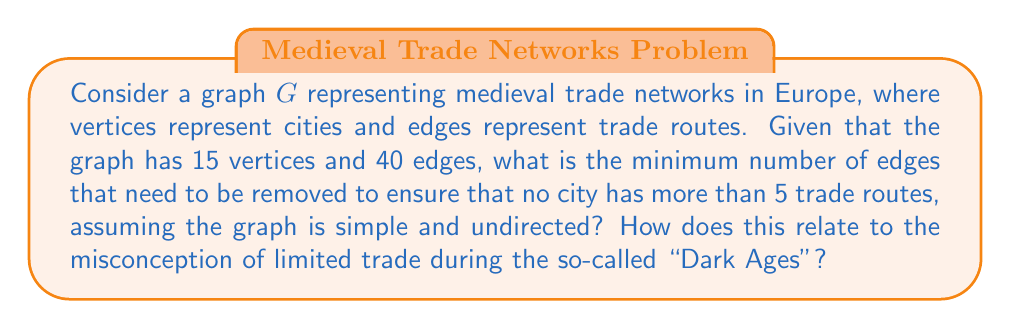Show me your answer to this math problem. To solve this problem, we need to follow these steps:

1) First, let's recall the handshaking lemma: In an undirected graph, the sum of all vertex degrees is equal to twice the number of edges. Mathematically, 
   
   $$\sum_{v \in V} \deg(v) = 2|E|$$

2) In our case, $|E| = 40$, so the sum of all degrees is $2 * 40 = 80$.

3) We want to ensure that no vertex has a degree greater than 5. The maximum possible sum of degrees while satisfying this condition is $5 * 15 = 75$, as there are 15 vertices.

4) The difference between the current sum of degrees (80) and the maximum allowed sum (75) is the minimum number of degree reductions needed:

   $$80 - 75 = 5$$

5) Each edge removal reduces the total degree sum by 2, as it affects two vertices. Therefore, the number of edges to be removed is:

   $$\frac{5}{2} = 2.5$$

6) Since we can't remove a fractional edge, we round up to the nearest integer: 3 edges.

This problem challenges the notion of the "Dark Ages" by demonstrating the complexity of medieval trade networks. The fact that we need to remove edges to limit trade routes suggests that medieval Europe had more extensive trade than often assumed. The graph theory model provides a quantitative way to analyze these networks, contradicting the idea of a simple, isolated medieval economy.
Answer: 3 edges need to be removed. 